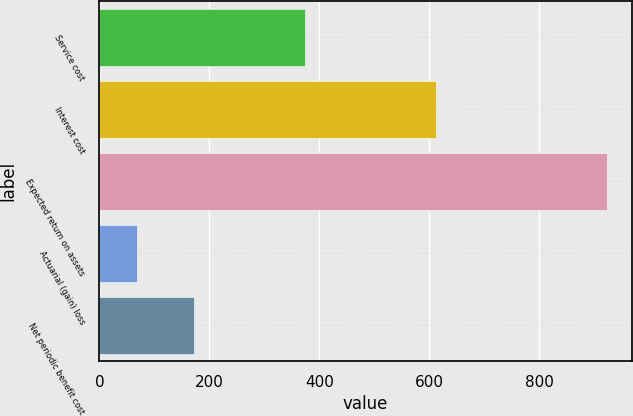Convert chart. <chart><loc_0><loc_0><loc_500><loc_500><bar_chart><fcel>Service cost<fcel>Interest cost<fcel>Expected return on assets<fcel>Actuarial (gain) loss<fcel>Net periodic benefit cost<nl><fcel>374<fcel>612<fcel>922<fcel>68<fcel>172<nl></chart> 